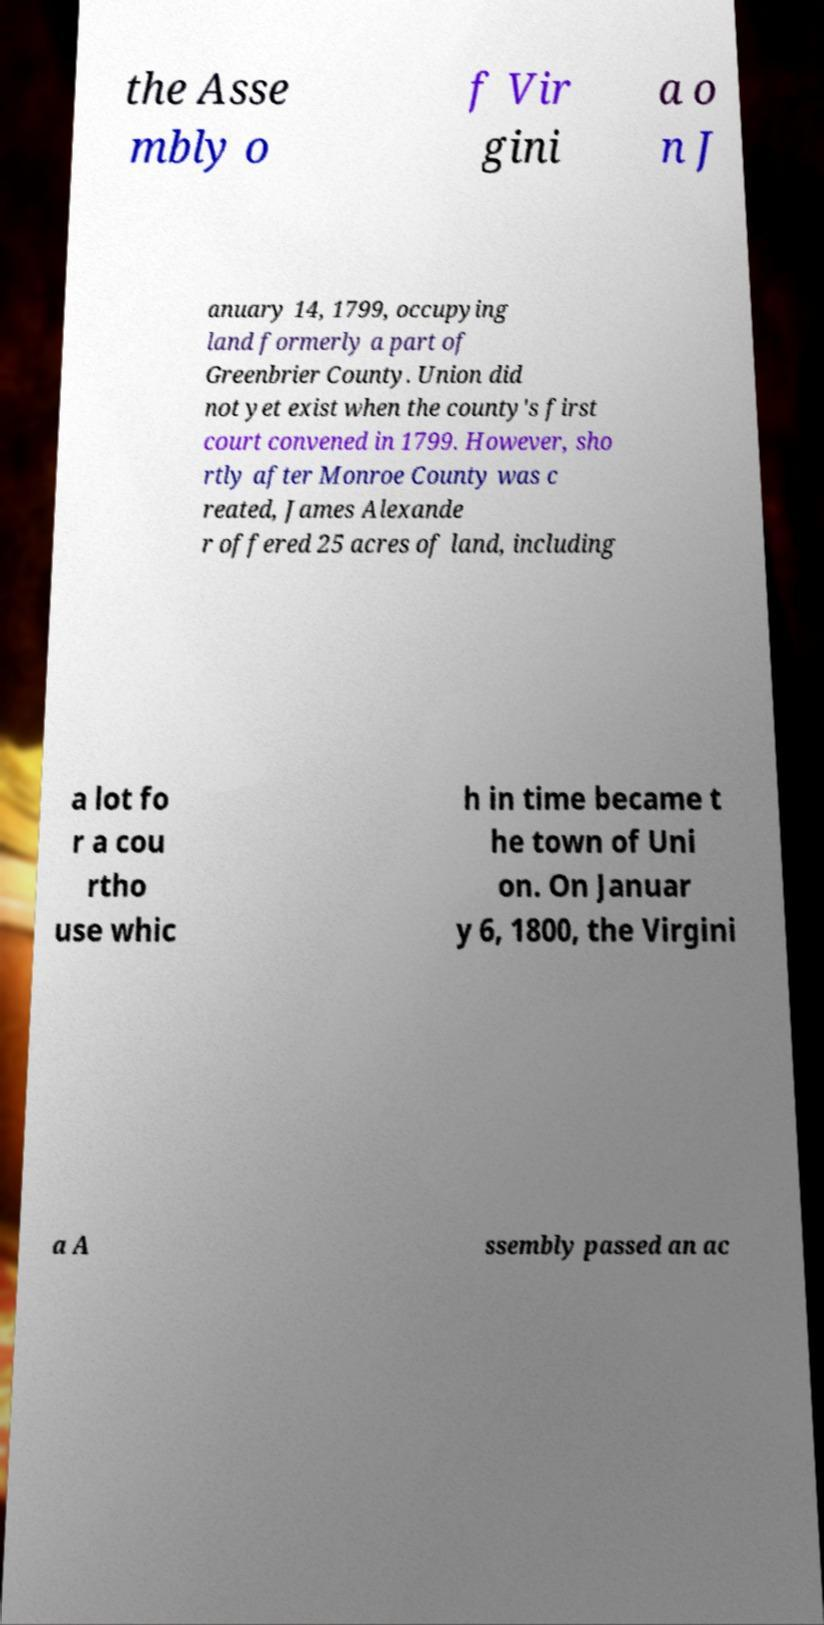For documentation purposes, I need the text within this image transcribed. Could you provide that? the Asse mbly o f Vir gini a o n J anuary 14, 1799, occupying land formerly a part of Greenbrier County. Union did not yet exist when the county's first court convened in 1799. However, sho rtly after Monroe County was c reated, James Alexande r offered 25 acres of land, including a lot fo r a cou rtho use whic h in time became t he town of Uni on. On Januar y 6, 1800, the Virgini a A ssembly passed an ac 